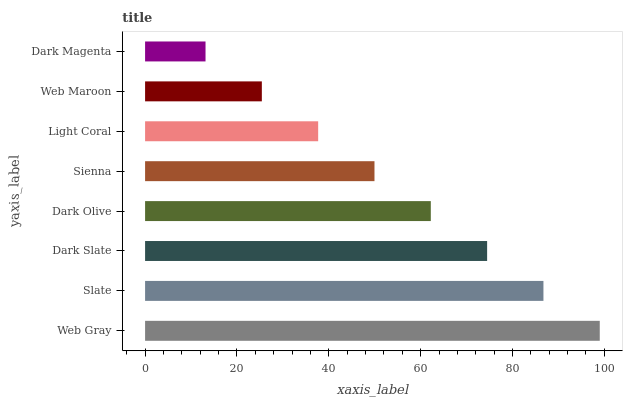Is Dark Magenta the minimum?
Answer yes or no. Yes. Is Web Gray the maximum?
Answer yes or no. Yes. Is Slate the minimum?
Answer yes or no. No. Is Slate the maximum?
Answer yes or no. No. Is Web Gray greater than Slate?
Answer yes or no. Yes. Is Slate less than Web Gray?
Answer yes or no. Yes. Is Slate greater than Web Gray?
Answer yes or no. No. Is Web Gray less than Slate?
Answer yes or no. No. Is Dark Olive the high median?
Answer yes or no. Yes. Is Sienna the low median?
Answer yes or no. Yes. Is Web Maroon the high median?
Answer yes or no. No. Is Light Coral the low median?
Answer yes or no. No. 